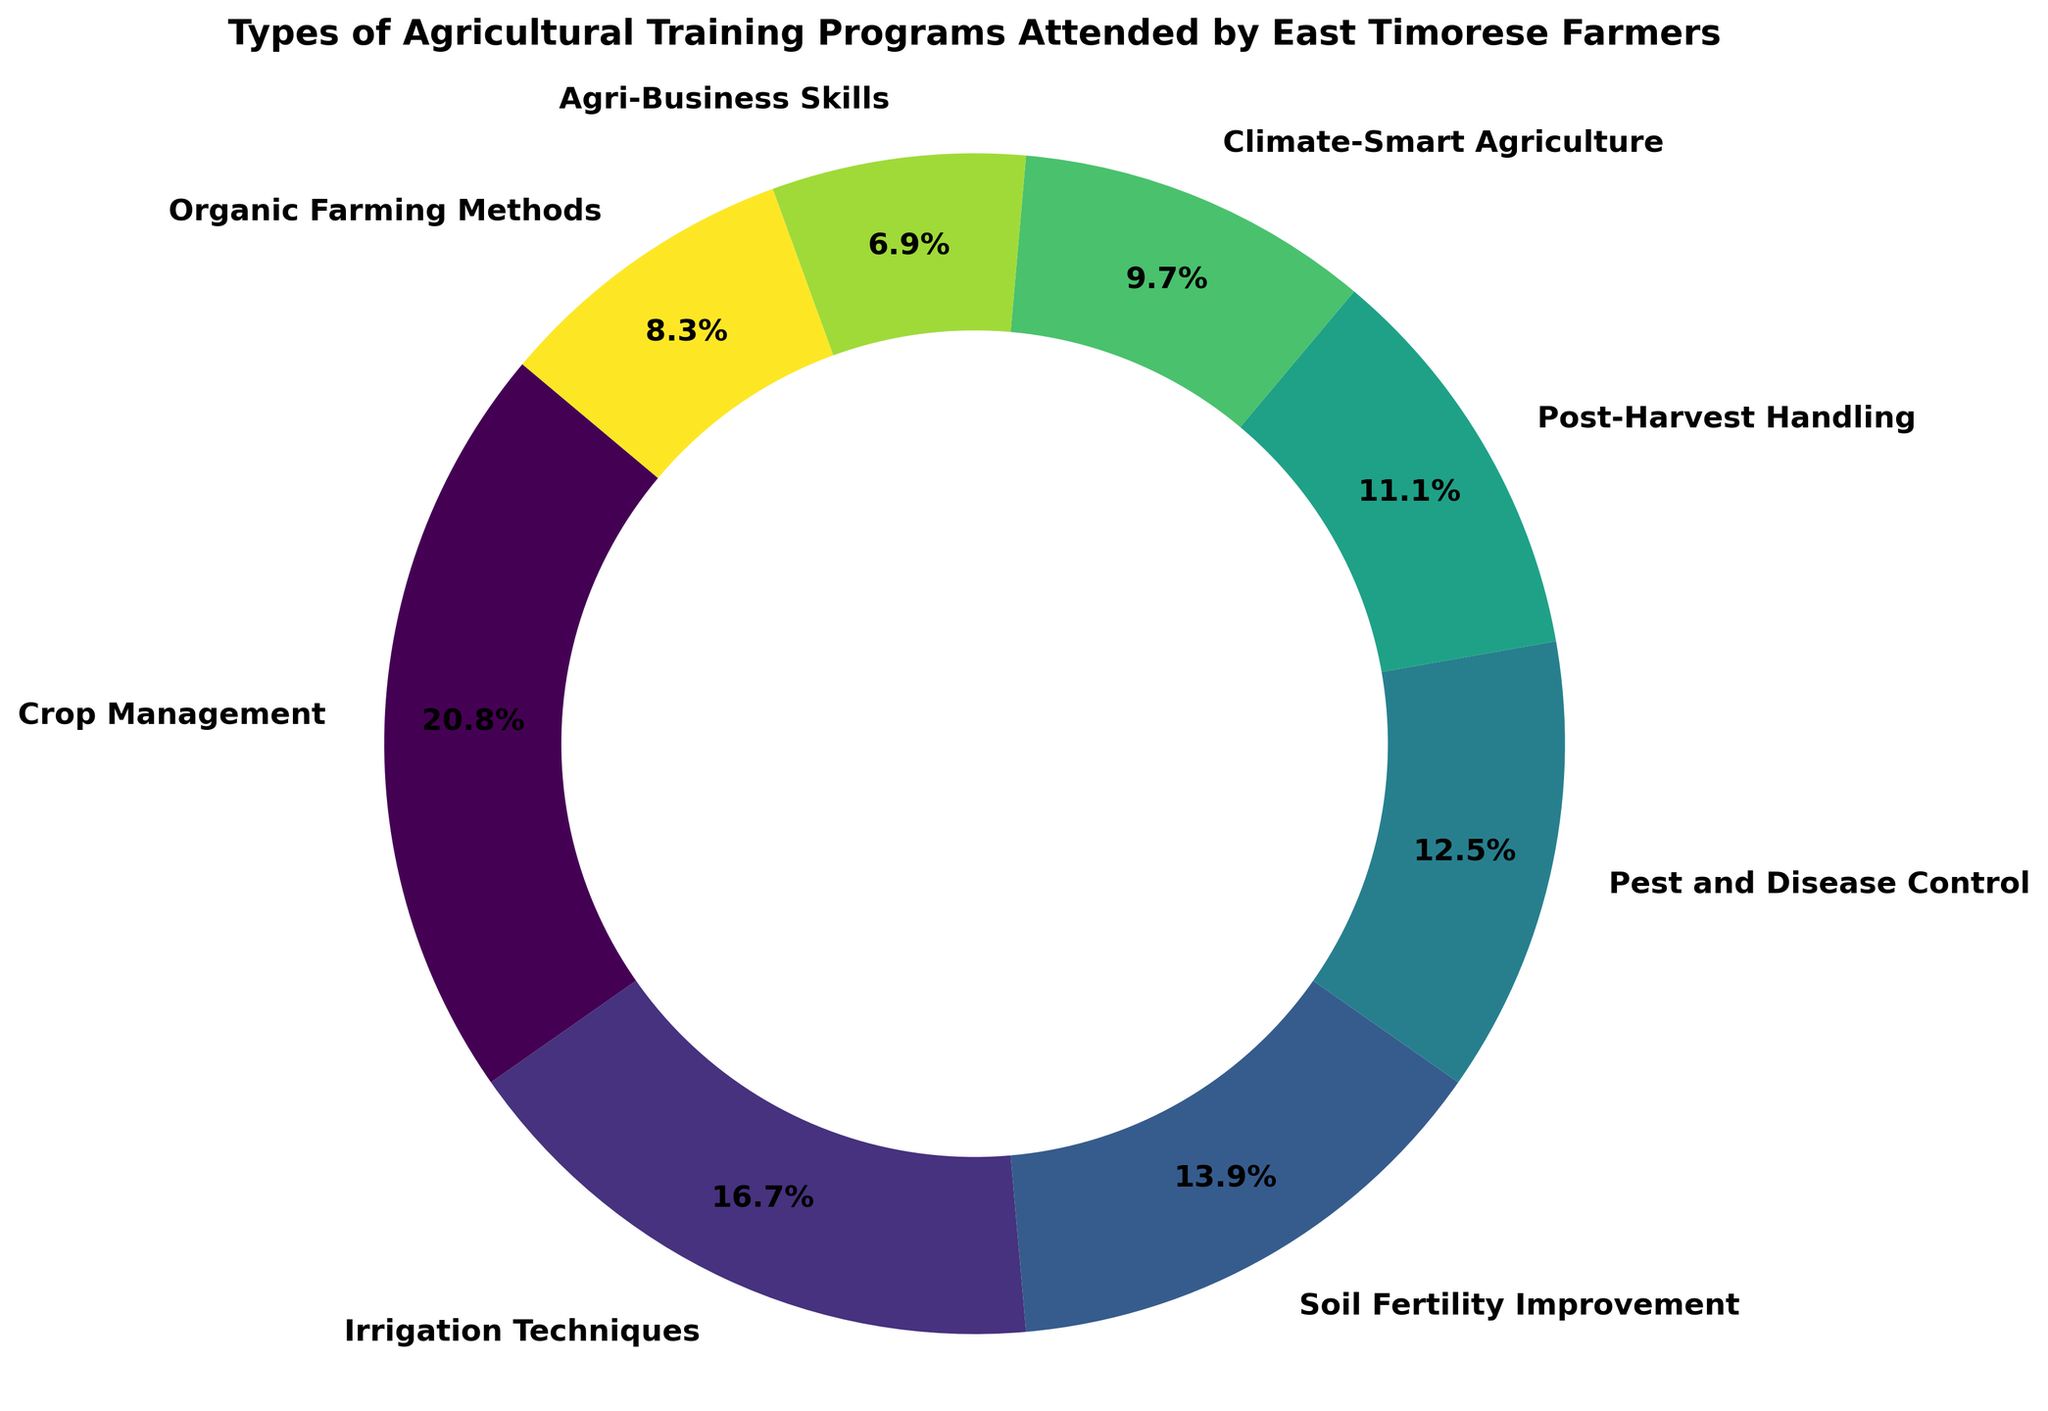What proportion of farmers attended Pest and Disease Control training? Pest and Disease Control training is represented as a wedge in the pie chart. According to the chart's labels, 90 farmers attended this program. The number of farmers who attended the training programs in total is the sum of all the farmers: 150 + 120 + 100 + 90 + 80 + 70 + 50 + 60 = 720. The proportion is (90/720) * 100 = 12.5%.
Answer: 12.5% Which training program was attended by the highest number of farmers? By observing the pie chart, the largest wedge and label indicate the highest value, which is 150 farmers for Crop Management.
Answer: Crop Management How many more farmers attended Crop Management training compared to Organic Farming Methods training? Crop Management was attended by 150 farmers and Organic Farming Methods by 60. The difference is 150 - 60 = 90 farmers.
Answer: 90 What is the sum of farmers who attended Agri-Business Skills and Climate-Smart Agriculture training? Agri-Business Skills training was attended by 50 farmers and Climate-Smart Agriculture by 70. The total is 50 + 70 = 120 farmers.
Answer: 120 Which training programs together account for exactly 30% of the total attendance? The total number of farmers attending the programs is 720. 30% of it is 0.3 * 720 = 216. Crop Management (150) plus Soil Fertility Improvement (100) equals 250, and other combinations do not match exactly to 216. Hence, no exact match.
Answer: None Compare the number of farmers attending Soil Fertility Improvement training to those attending Post-Harvest Handling training. Which is higher? According to the chart, Soil Fertility Improvement was attended by 100 farmers while Post-Harvest Handling by 80 farmers. Soil Fertility Improvement has the higher attendance.
Answer: Soil Fertility Improvement What percentage of farmers attended either Irrigation Techniques or Pest and Disease Control training? Irrigation Techniques had 120 farmers, and Pest and Disease Control had 90. The total is 120 + 90 = 210 farmers. The percentage is (210/720) * 100 = 29.2%.
Answer: 29.2% Which section of the chart is smaller: Organic Farming Methods or Agri-Business Skills, and by how much? Organic Farming Methods had 60 farmers, and Agri-Business Skills had 50. Organic Farming Methods is larger by 60 - 50 = 10 farmers.
Answer: Agri-Business Skills by 10 